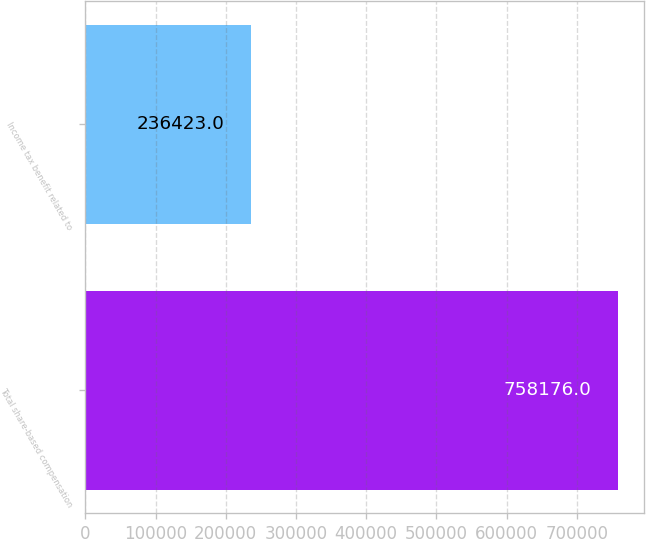<chart> <loc_0><loc_0><loc_500><loc_500><bar_chart><fcel>Total share-based compensation<fcel>Income tax benefit related to<nl><fcel>758176<fcel>236423<nl></chart> 